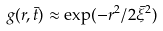Convert formula to latex. <formula><loc_0><loc_0><loc_500><loc_500>g ( r , { \bar { t } } ) \approx \exp ( - r ^ { 2 } / 2 { \bar { \xi } } ^ { 2 } )</formula> 